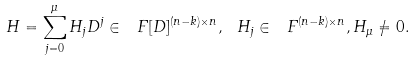<formula> <loc_0><loc_0><loc_500><loc_500>H = \sum _ { j = 0 } ^ { \mu } H _ { j } D ^ { j } \in \ F [ D ] ^ { ( n - k ) \times n } , \ H _ { j } \in \ F ^ { ( n - k ) \times n } , H _ { \mu } \not = 0 .</formula> 